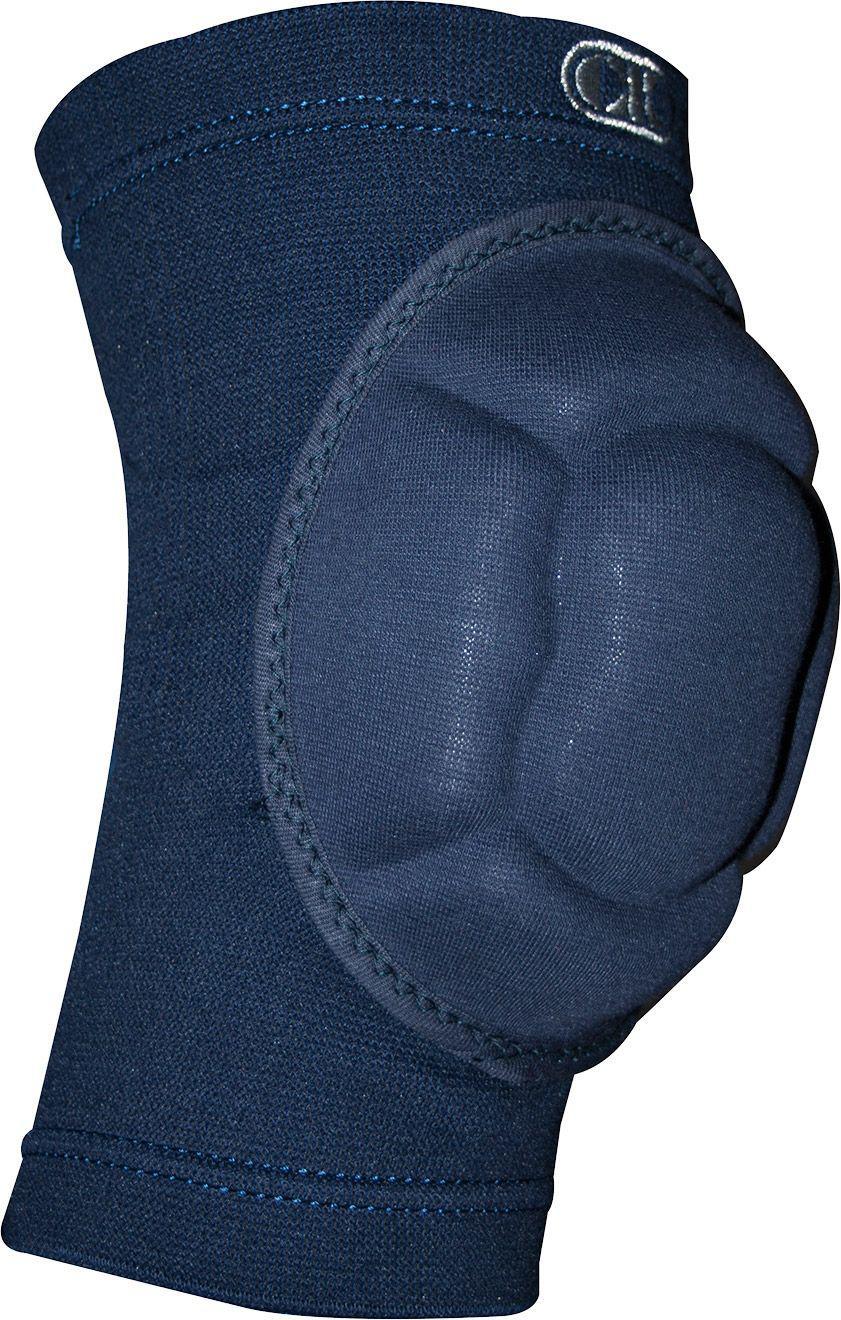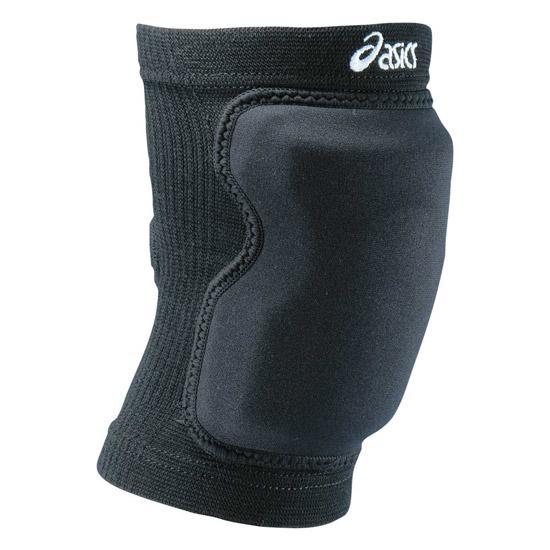The first image is the image on the left, the second image is the image on the right. For the images displayed, is the sentence "Images each show one knee pad, and pads are turned facing the same direction." factually correct? Answer yes or no. Yes. 